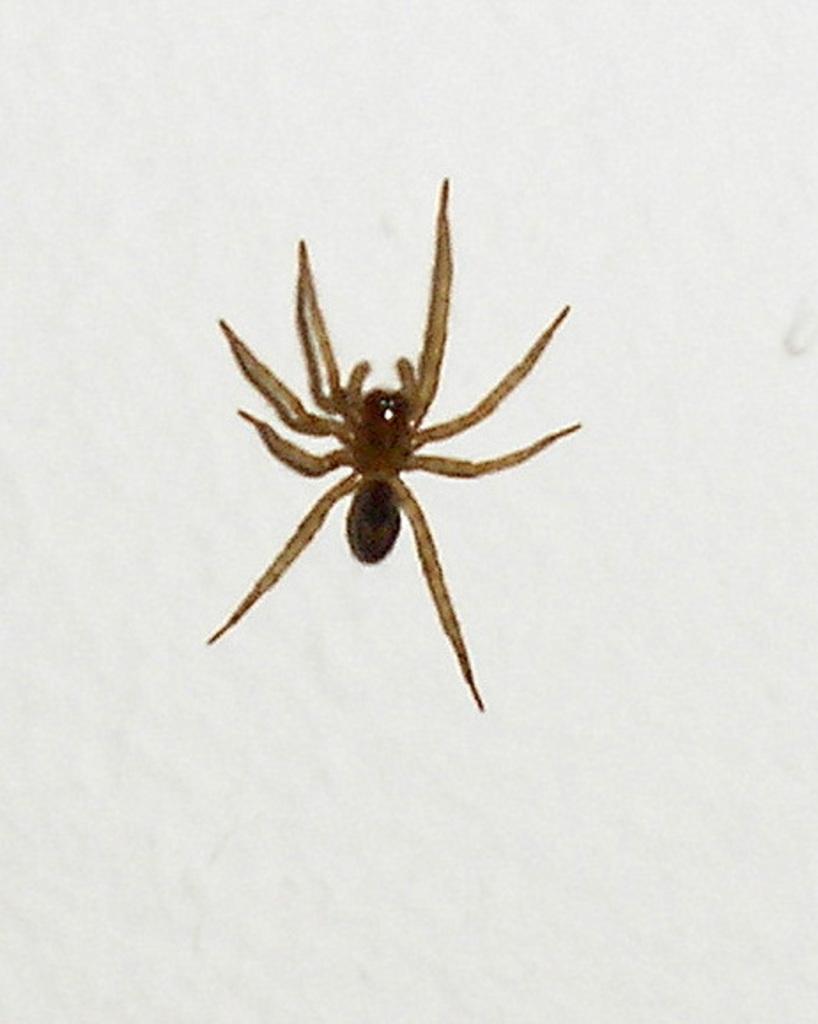How would you summarize this image in a sentence or two? In the middle of this image, there is a spider on a surface. And the background is white in color. 